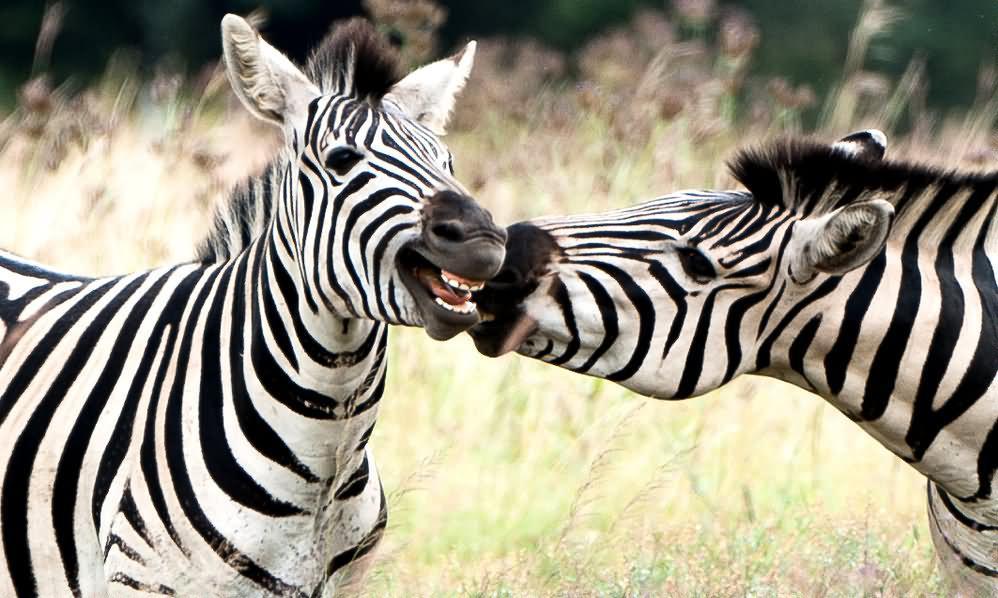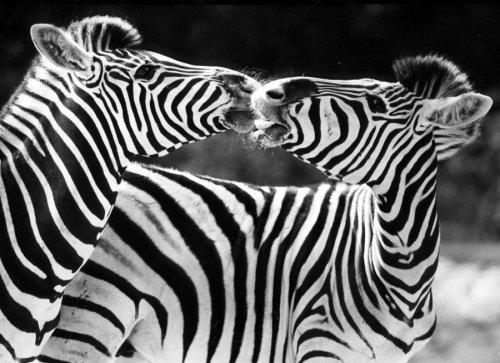The first image is the image on the left, the second image is the image on the right. Analyze the images presented: Is the assertion "The right image contains two zebras with their noses touching, and the left image contains three zebras, with two facing each other over the body of the one in the middle." valid? Answer yes or no. No. The first image is the image on the left, the second image is the image on the right. Considering the images on both sides, is "The left and right image contains the same number of zebras." valid? Answer yes or no. Yes. 